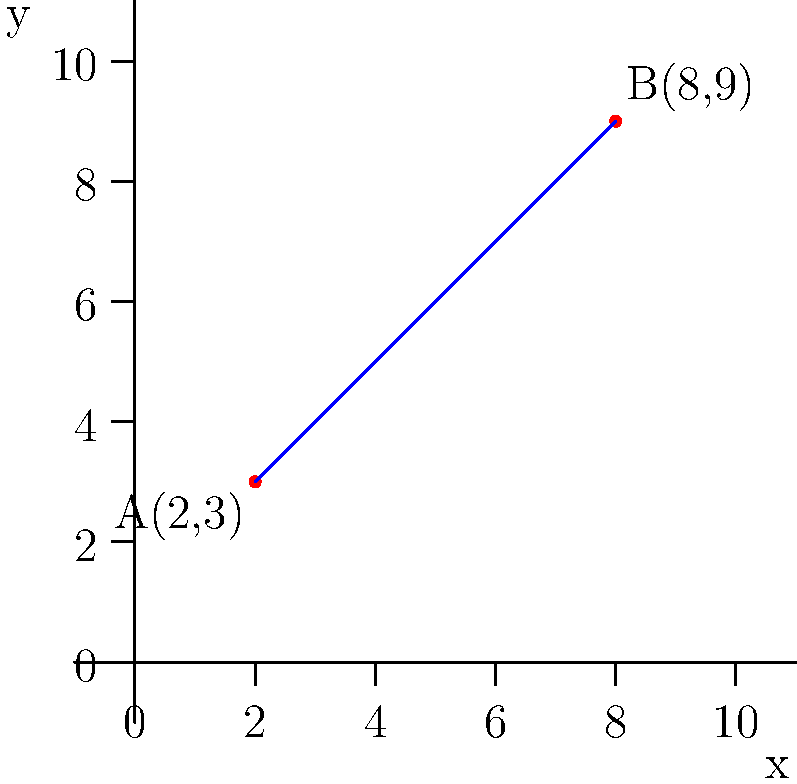In a copyright infringement case, you're analyzing a photograph where two key elements are located at points A(2,3) and B(8,9) on a coordinate grid overlaid on the image. To determine if the composition is substantially similar to another work, you need to calculate the slope of the line connecting these two points. What is the slope of line AB? To find the slope of a line connecting two points, we use the slope formula:

$$ m = \frac{y_2 - y_1}{x_2 - x_1} $$

Where $(x_1, y_1)$ are the coordinates of the first point and $(x_2, y_2)$ are the coordinates of the second point.

Given:
- Point A: $(2, 3)$
- Point B: $(8, 9)$

Let's plug these values into the formula:

$$ m = \frac{9 - 3}{8 - 2} = \frac{6}{6} = 1 $$

Therefore, the slope of line AB is 1.

This means that for every 1 unit increase in x, y also increases by 1 unit, indicating a 45-degree angle between the line and the x-axis.
Answer: 1 